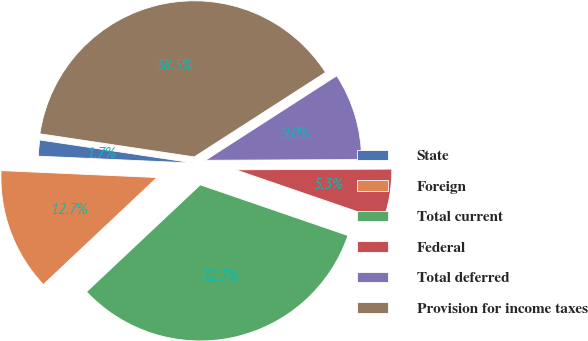Convert chart to OTSL. <chart><loc_0><loc_0><loc_500><loc_500><pie_chart><fcel>State<fcel>Foreign<fcel>Total current<fcel>Federal<fcel>Total deferred<fcel>Provision for income taxes<nl><fcel>1.66%<fcel>12.72%<fcel>32.72%<fcel>5.34%<fcel>9.03%<fcel>38.53%<nl></chart> 